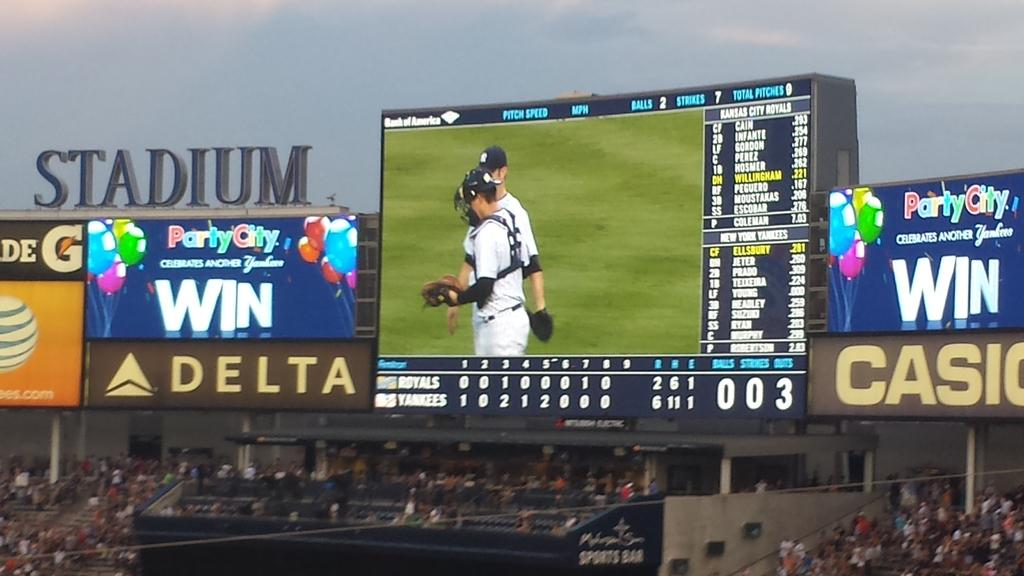<image>
Write a terse but informative summary of the picture. A baseball stadium with a Delta Ad and a large screen above the stands. 